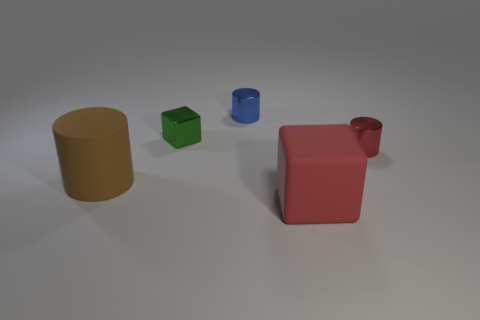What size is the red metallic object that is the same shape as the blue object?
Give a very brief answer. Small. There is a tiny cylinder that is behind the tiny red metal object; how many green cubes are in front of it?
Your answer should be compact. 1. Does the tiny cylinder that is left of the red block have the same material as the block that is on the right side of the tiny blue shiny thing?
Give a very brief answer. No. What number of green objects have the same shape as the red matte thing?
Keep it short and to the point. 1. What number of small objects have the same color as the matte cube?
Provide a succinct answer. 1. Does the large thing behind the red matte cube have the same shape as the matte object on the right side of the tiny blue shiny cylinder?
Your answer should be very brief. No. There is a large matte thing on the right side of the rubber object on the left side of the small blue thing; how many big red blocks are to the left of it?
Keep it short and to the point. 0. The large brown object behind the rubber object on the right side of the block that is behind the large red rubber thing is made of what material?
Ensure brevity in your answer.  Rubber. Does the red thing that is in front of the red shiny object have the same material as the small green block?
Ensure brevity in your answer.  No. What number of matte blocks have the same size as the blue cylinder?
Keep it short and to the point. 0. 